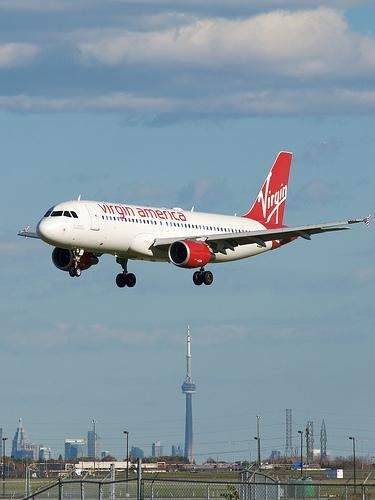Question: what is this a pic of?
Choices:
A. A clear blue sky.
B. An airport.
C. A plane flying.
D. An air show.
Answer with the letter. Answer: C Question: when was this pic taken?
Choices:
A. In the morning.
B. At midday.
C. During the daytime.
D. In the night.
Answer with the letter. Answer: C Question: what is written in red?
Choices:
A. Delta.
B. Virgin america.
C. Southwest.
D. Luftansa.
Answer with the letter. Answer: B Question: what is tall in the background?
Choices:
A. A tower.
B. A light pole.
C. A building.
D. A silo.
Answer with the letter. Answer: C Question: why is the landing gear down?
Choices:
A. The plane just took off.
B. The plane is going to land.
C. The landing gear is broken.
D. The pilot forgot to retract the landing gear.
Answer with the letter. Answer: B 